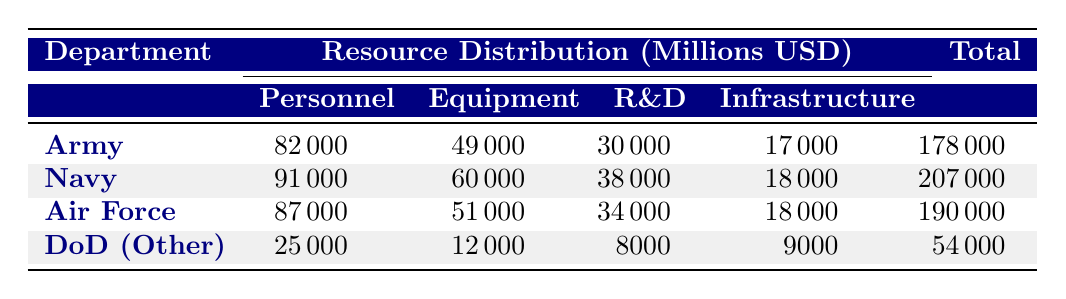What is the total funding for the Department of the Navy? The table indicates that the total funding for the Department of the Navy is listed in the last column under the Navy row, which shows the value of 207000.
Answer: 207000 What is the personnel funding amount for the Department of Defense (Other)? The table provides a row for the Department of Defense (Other), and the personnel funding amount is found in the second column of that row, which is 25000.
Answer: 25000 Which department has the highest allocation for Research and Development? By examining the R&D values in the table, the Department of the Navy has the highest allocation with 38000 in the R&D column.
Answer: Department of the Navy What is the difference in total funding between the Department of the Army and the Department of the Air Force? The total funding for the Department of the Army is 178000, and for the Air Force, it is 190000. The difference is calculated as 190000 - 178000 = 12000.
Answer: 12000 Is the funding for Equipment greater than the funding for Infrastructure in the Department of the Army? In the Army row, the Equipment allocation is 49000 and the Infrastructure allocation is 17000. Since 49000 > 17000, the statement is true.
Answer: Yes What is the average funding allocated to Personnel across all departments? Sum the Personnel allocations: 82000 + 91000 + 87000 + 25000 = 285000, and divide by the number of departments (4) to get the average, which is 285000 / 4 = 71250.
Answer: 71250 Which department has the lowest total funding, and what is that amount? Looking at the Total funding column, the lowest value is 54000, associated with the Department of Defense (Other).
Answer: Department of Defense (Other), 54000 What percentage of the Department of the Air Force's total funding is allocated to Research and Development? The Department of the Air Force has a total funding of 190000 and R&D funding of 34000. The percentage is calculated as (34000 / 190000) * 100 = 17.89%.
Answer: 17.89% Which department spends more on Equipment, the Department of the Army or the Department of the Air Force? The Army allocates 49000 for Equipment and the Air Force allocates 51000. Since 51000 is greater than 49000, the Air Force spends more.
Answer: Department of the Air Force 